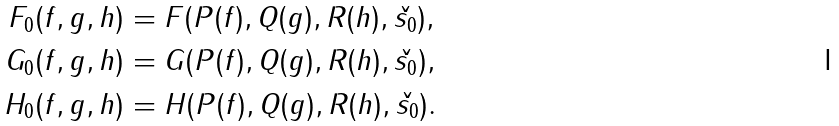Convert formula to latex. <formula><loc_0><loc_0><loc_500><loc_500>F _ { 0 } ( f , g , h ) & = F ( P ( f ) , Q ( g ) , R ( h ) , \check { s _ { 0 } } ) , \\ G _ { 0 } ( f , g , h ) & = G ( P ( f ) , Q ( g ) , R ( h ) , \check { s _ { 0 } } ) , \\ H _ { 0 } ( f , g , h ) & = H ( P ( f ) , Q ( g ) , R ( h ) , \check { s _ { 0 } } ) .</formula> 